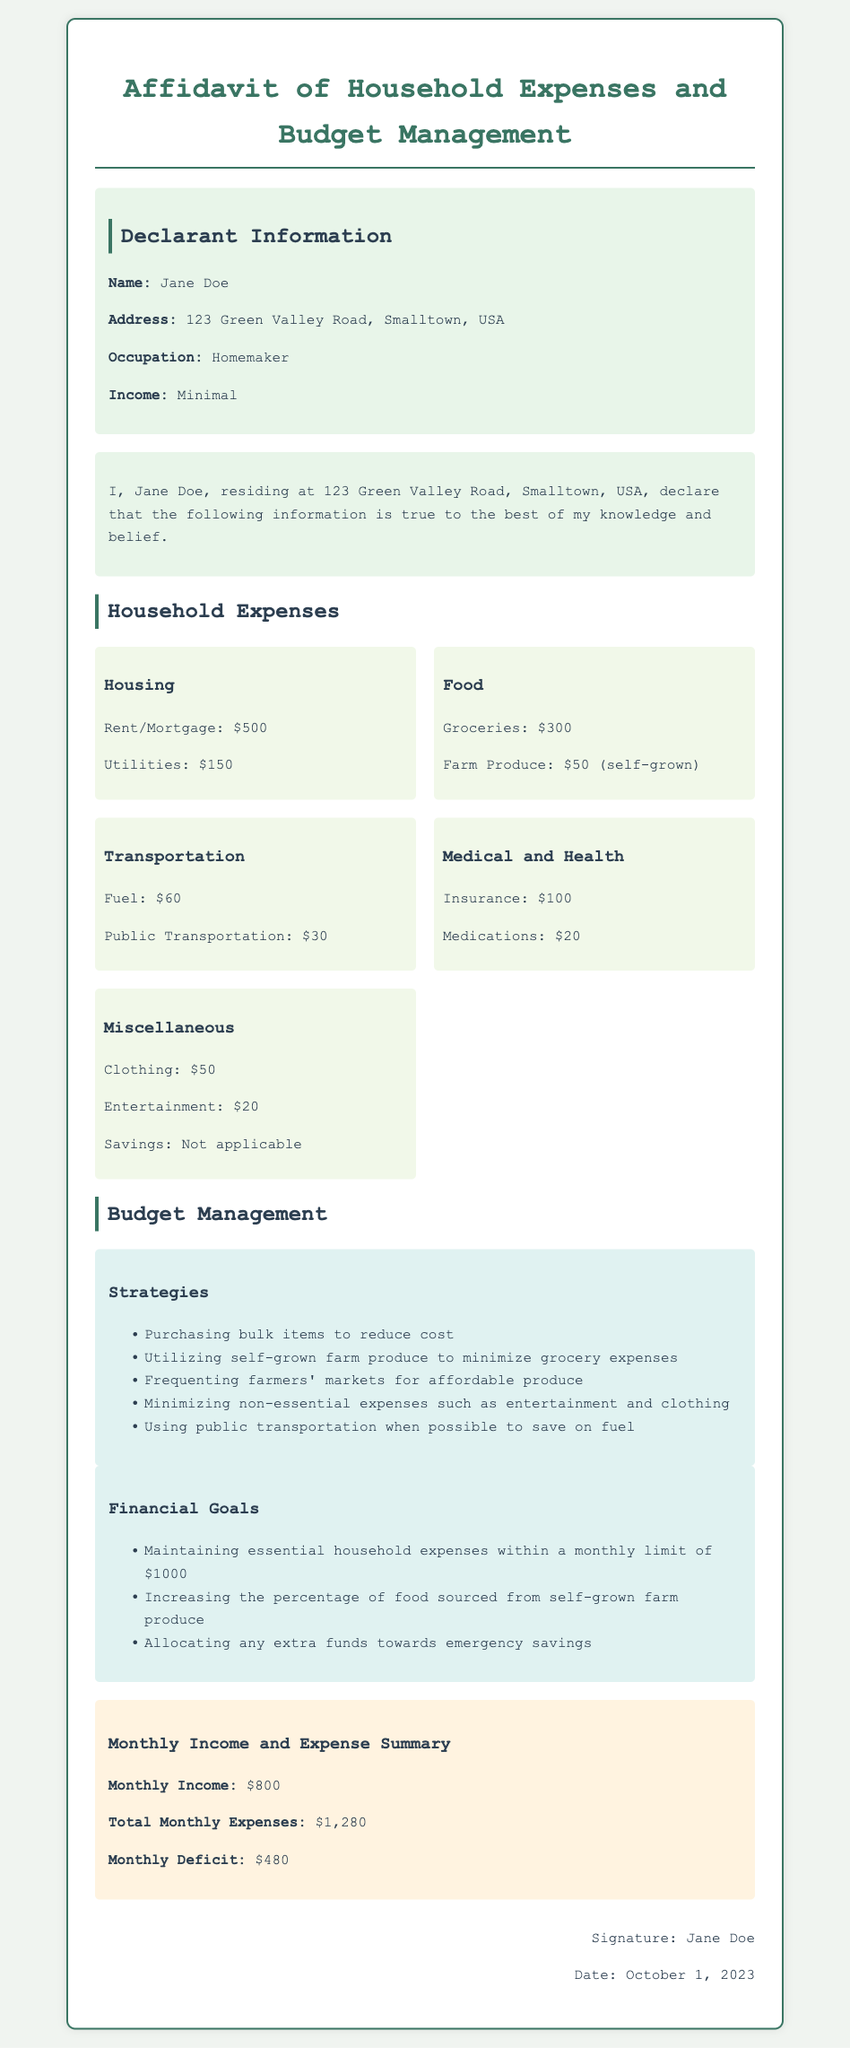What is the name of the declarant? The name of the declarant is stated in the document, which is Jane Doe.
Answer: Jane Doe What is the monthly income? The monthly income is specified in the summary section of the document.
Answer: $800 How much is allocated for groceries? The grocery allocation is detailed in the household expenses section.
Answer: $300 What are the savings listed? The document includes a section on miscellaneous expenses that mentions savings.
Answer: Not applicable What is the total monthly deficit? The monthly deficit is derived from the income and expenses outlined in the summary.
Answer: $480 Which strategy involves reducing grocery expenses? One of the strategies focuses on minimizing grocery costs through self-grown produce.
Answer: Utilizing self-grown farm produce What is the address of the declarant? The address of the declarant is included in the declarant information section.
Answer: 123 Green Valley Road, Smalltown, USA What is the total monthly expense amount? The total monthly expenses can be found in the summary of the document.
Answer: $1,280 Which category has the highest expense? The expenses are detailed under different categories, allowing us to determine which is the highest.
Answer: Housing 